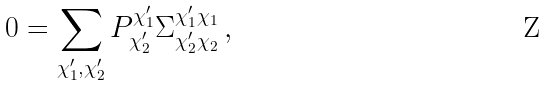<formula> <loc_0><loc_0><loc_500><loc_500>0 = \sum _ { \chi _ { 1 } ^ { \prime } , \chi _ { 2 } ^ { \prime } } P _ { \chi ^ { \prime } _ { 2 } } ^ { \chi ^ { \prime } _ { 1 } } \Sigma _ { \chi _ { 2 } ^ { \prime } \chi _ { 2 } } ^ { \chi _ { 1 } ^ { \prime } \chi _ { 1 } } \, ,</formula> 